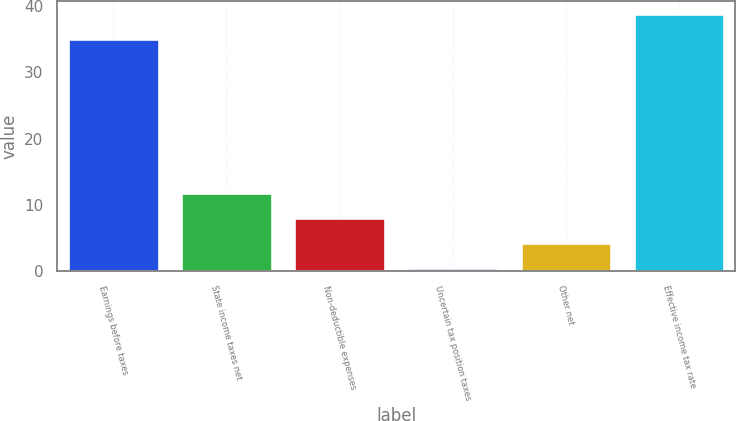<chart> <loc_0><loc_0><loc_500><loc_500><bar_chart><fcel>Earnings before taxes<fcel>State income taxes net<fcel>Non-deductible expenses<fcel>Uncertain tax position taxes<fcel>Other net<fcel>Effective income tax rate<nl><fcel>35<fcel>11.75<fcel>8<fcel>0.5<fcel>4.25<fcel>38.75<nl></chart> 